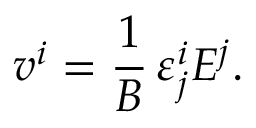Convert formula to latex. <formula><loc_0><loc_0><loc_500><loc_500>v ^ { i } = \frac { 1 } { B } \, \varepsilon _ { j } ^ { i } E ^ { j } .</formula> 